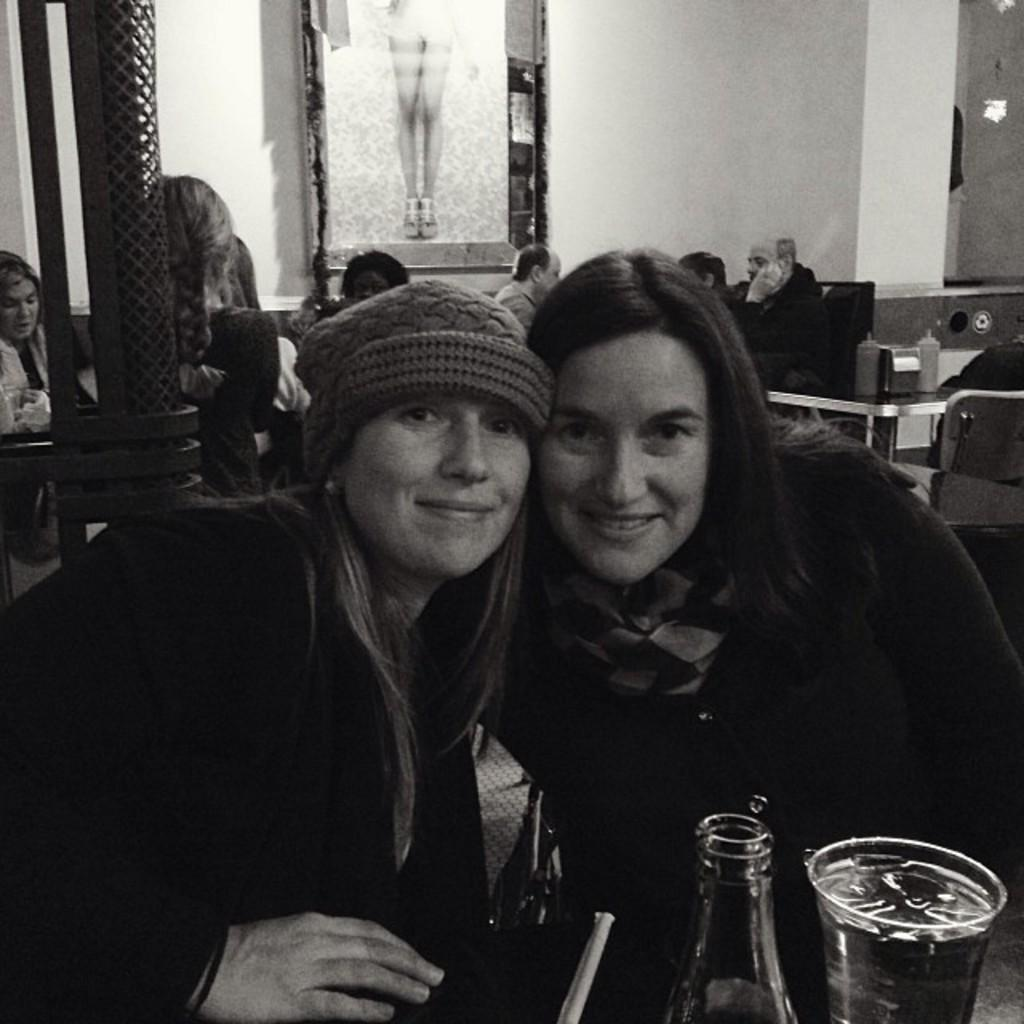How many people are in the image? There are people in the image, but the exact number is not specified. What color of clothing are some of the people wearing? Some of the people are wearing black color dress. What objects are in front of the people? There is a bottle and a glass in front of the people. Can you tell me how many geese are present in the image? There are no geese present in the image. What type of place is depicted in the image? The facts provided do not give any information about the type of place depicted in the image. 